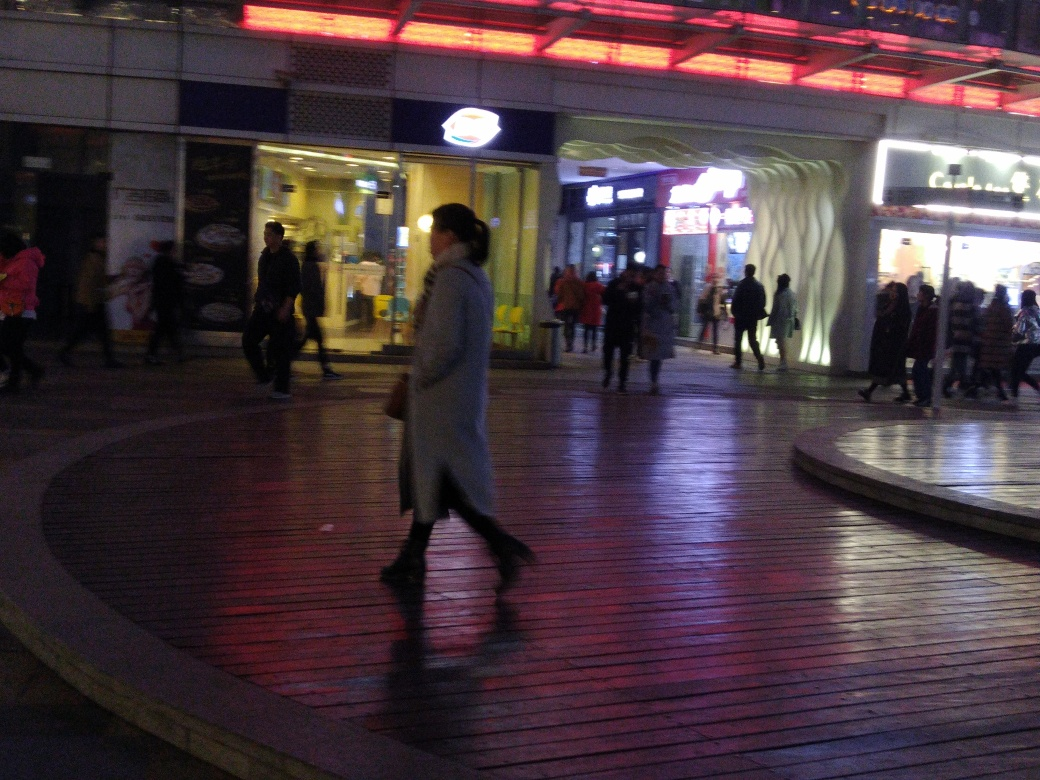Does the image have average composition? Based on the principles of photographic composition, such as balance, framing, and the rule of thirds, the image reflects a candid and dynamic scene typically observed in urban night settings. The composition captures the movement of people and the ambient lighting, which contributes to a sense of liveliness. Although the central figure is slightly offset, thereby deviating from a classic symmetrical balance, this offset can add a heightened sense of motion and a more natural feel to the scene. Therefore, the composition is effective in conveying the atmosphere but might not fit traditional definitions of 'average.' 